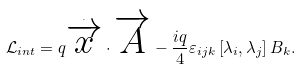<formula> <loc_0><loc_0><loc_500><loc_500>\mathcal { L } _ { i n t } = q \overset { _ { \cdot } } { \overrightarrow { x } } \cdot \overrightarrow { A } - \frac { i q } { 4 } \varepsilon _ { i j k } \left [ \lambda _ { i } , \lambda _ { j } \right ] B _ { k } .</formula> 